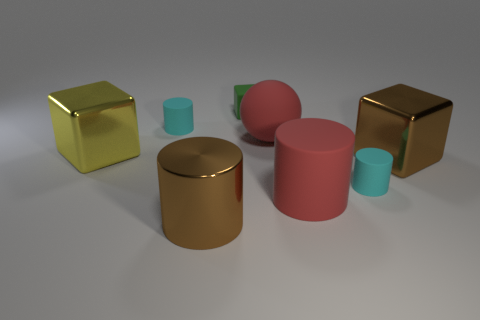Subtract 1 cylinders. How many cylinders are left? 3 Add 1 big yellow shiny cubes. How many objects exist? 9 Subtract all cubes. How many objects are left? 5 Add 6 cyan things. How many cyan things are left? 8 Add 3 small green metal cylinders. How many small green metal cylinders exist? 3 Subtract 0 cyan spheres. How many objects are left? 8 Subtract all brown cylinders. Subtract all small green objects. How many objects are left? 6 